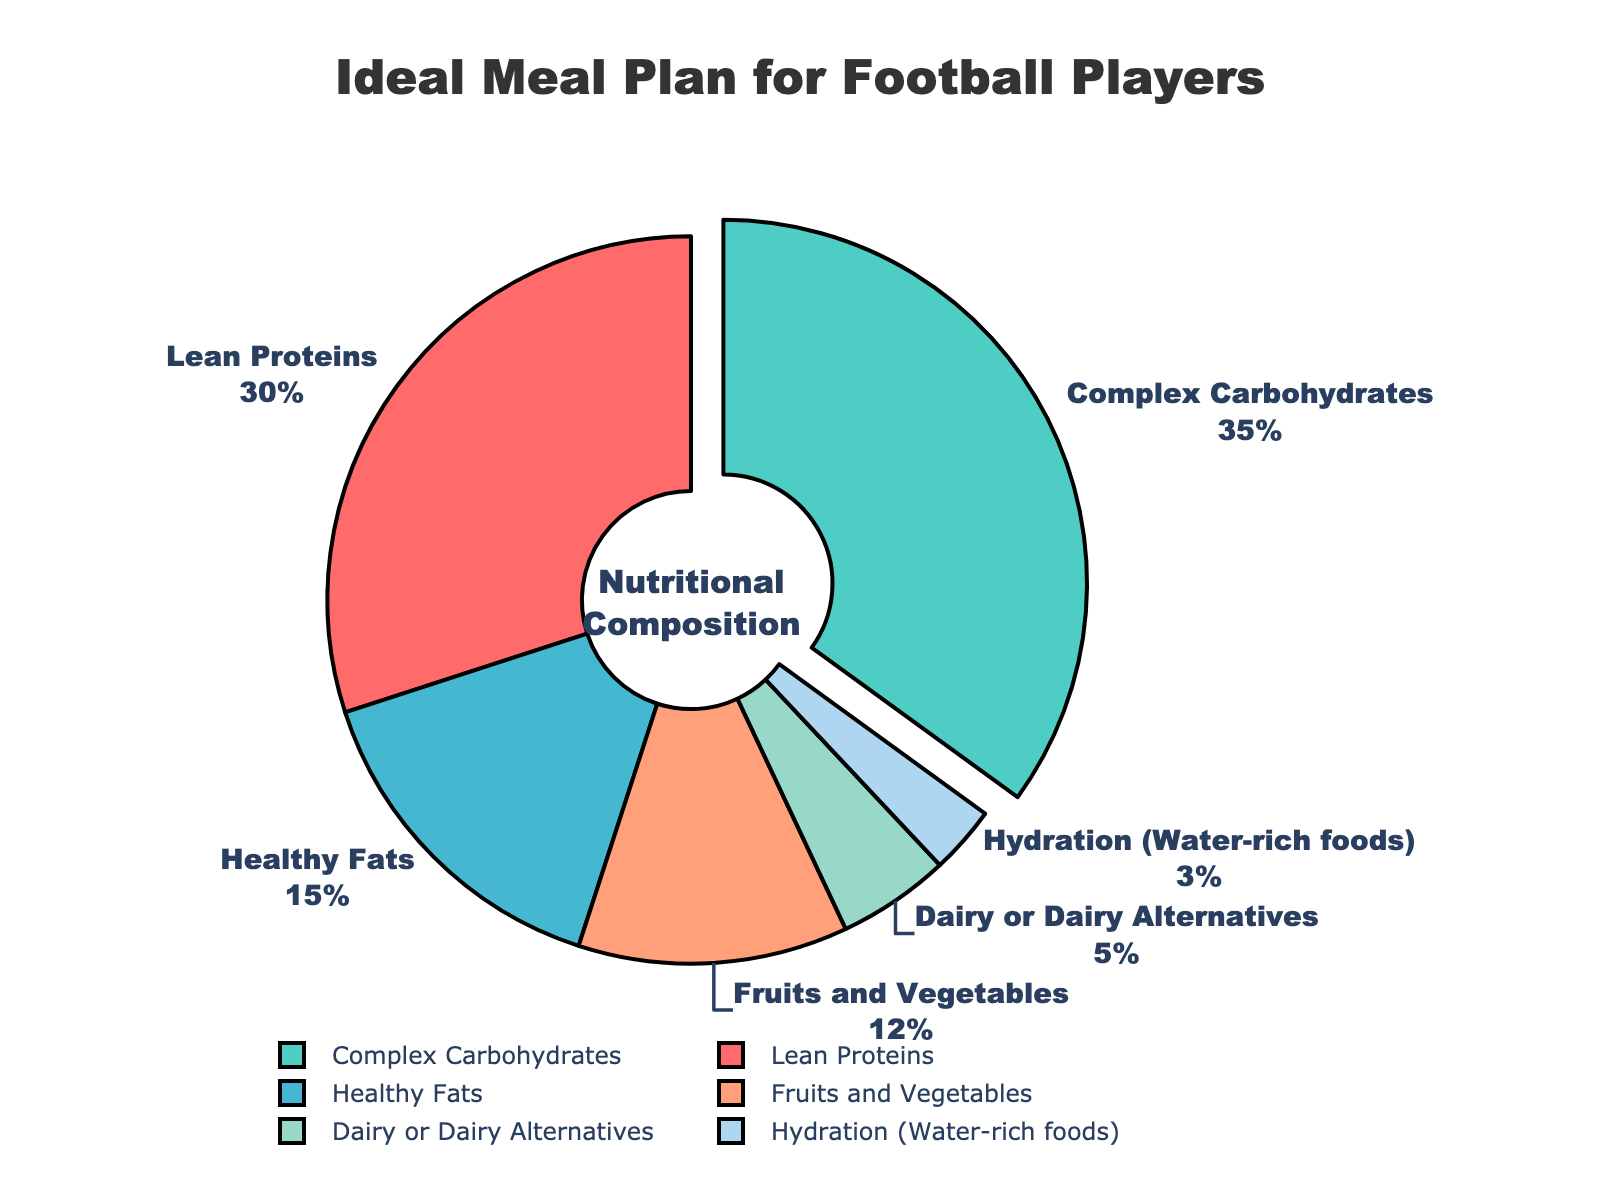Which nutrient has the highest percentage in the meal plan? The chart clearly shows each nutrient's percentage, and Complex Carbohydrates has the highest value, highlighted by being pulled out from the pie.
Answer: Complex Carbohydrates What is the combined percentage of Lean Proteins and Healthy Fats? Sum the percentages of Lean Proteins (30%) and Healthy Fats (15%). 30 + 15 = 45
Answer: 45% How does the percentage of Fruits and Vegetables compare to Dairy or Dairy Alternatives? Fruits and Vegetables have a percentage of 12%, while Dairy or Dairy Alternatives have 5%. 12 is greater than 5.
Answer: Fruits and Vegetables is greater Which nutrient has the smallest contribution to the meal plan? Look for the smallest value on the pie chart, which is Hydration (Water-rich foods) at 3%.
Answer: Hydration (Water-rich foods) What is the difference in percentage between Complex Carbohydrates and Healthy Fats? Subtract Healthy Fats percentage (15%) from Complex Carbohydrates percentage (35%). 35 - 15 = 20
Answer: 20 What is the proportion of Healthy Fats relative to Lean Proteins in the meal plan? Divide the percentage of Healthy Fats (15%) by Lean Proteins (30%). 15/30 = 0.5
Answer: 0.5 Which nutrient categories together make up more than half of the meal plan? Sum the largest nutrient categories until exceeding 50%. Complex Carbohydrates (35%) + Lean Proteins (30%) = 65%
Answer: Complex Carbohydrates and Lean Proteins What is the combined percentage of non-carbohydrate nutrients? Sum all percentages except Complex Carbohydrates (35%). 30 + 15 + 12 + 5 + 3 = 65
Answer: 65% What percentage of the meal plan is made up of micronutrient-heavy foods (Fruits and Vegetables plus Hydration)? Sum the percentages of Fruits and Vegetables (12%) and Hydration (3%). 12 + 3 = 15
Answer: 15% How does Lean Proteins' percentage compare visually to Healthy Fats? Lean Proteins (30%) occupies a larger section of the pie and is colored differently compared to Healthy Fats (15%).
Answer: Lean Proteins is larger 